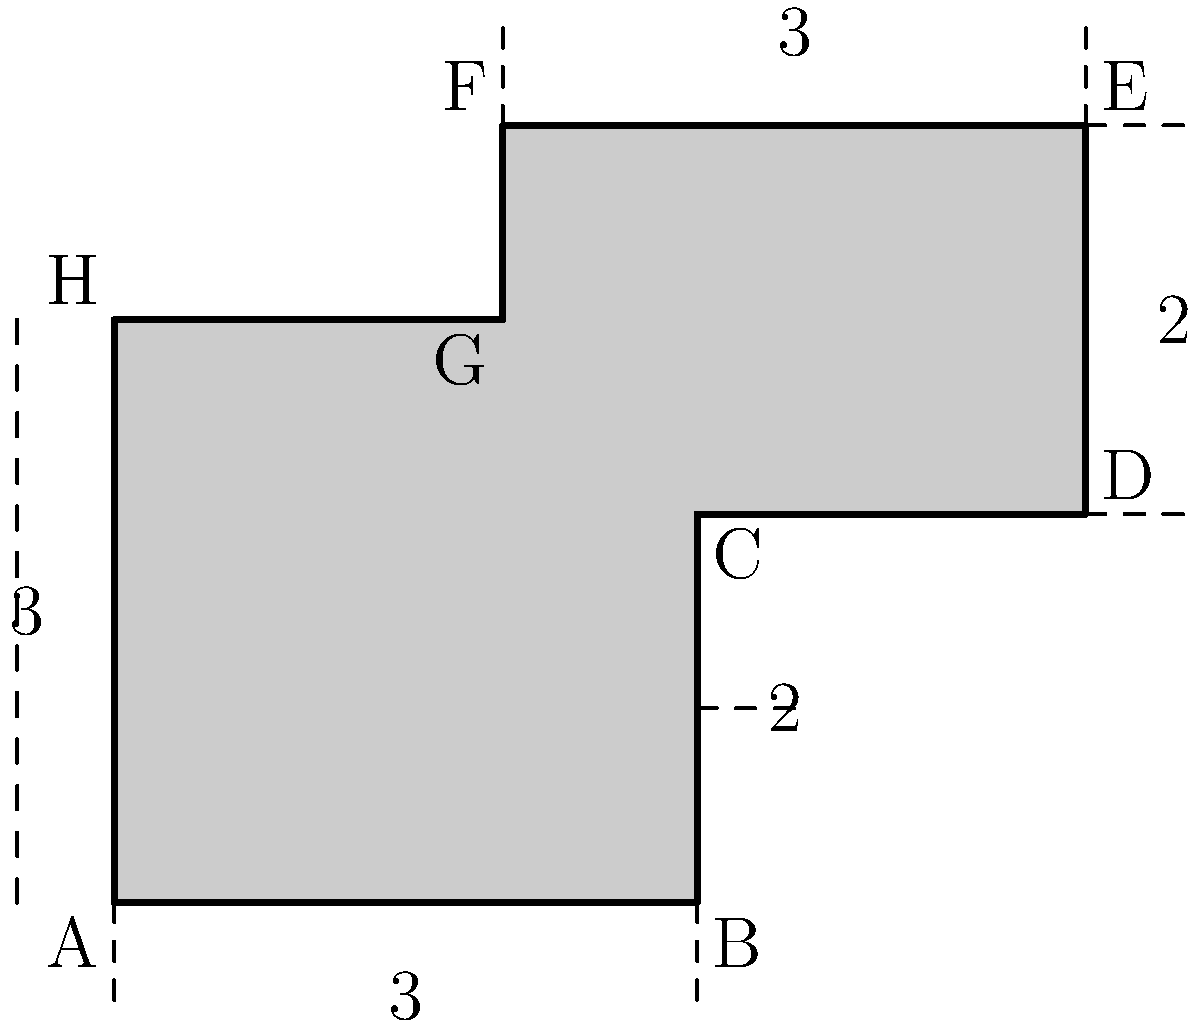You've extracted a complex shape from a PNG image as part of your iOS image processing library. The shape is represented by the polygon ABCDEFGH in the diagram. Given that each unit in the diagram represents 10 pixels, calculate the perimeter of this shape in pixels. To calculate the perimeter, we need to sum up the lengths of all sides of the polygon. Let's break it down step by step:

1) Side AB: 3 units = $3 \times 10 = 30$ pixels
2) Side BC: 2 units = $2 \times 10 = 20$ pixels
3) Side CD: 2 units = $2 \times 10 = 20$ pixels
4) Side DE: 2 units = $2 \times 10 = 20$ pixels
5) Side EF: 3 units = $3 \times 10 = 30$ pixels
6) Side FG: 1 unit = $1 \times 10 = 10$ pixels
7) Side GH: 2 units = $2 \times 10 = 20$ pixels
8) Side HA: 3 units = $3 \times 10 = 30$ pixels

Now, we sum up all these lengths:

$$ \text{Perimeter} = 30 + 20 + 20 + 20 + 30 + 10 + 20 + 30 = 180 \text{ pixels} $$

Therefore, the perimeter of the shape is 180 pixels.
Answer: 180 pixels 